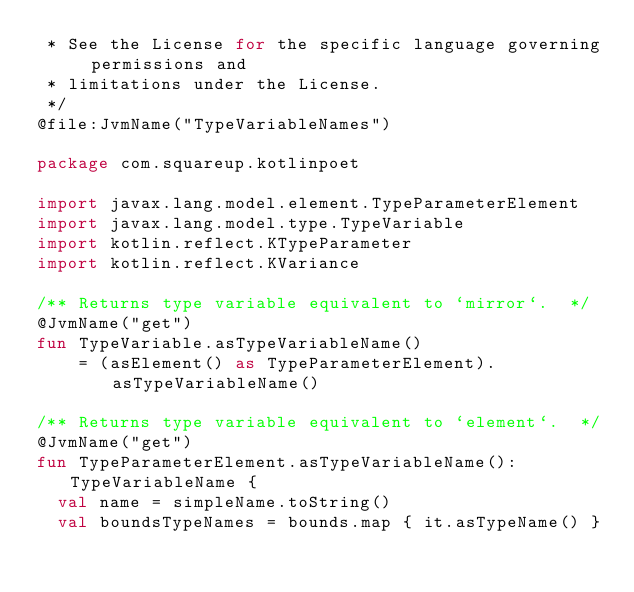Convert code to text. <code><loc_0><loc_0><loc_500><loc_500><_Kotlin_> * See the License for the specific language governing permissions and
 * limitations under the License.
 */
@file:JvmName("TypeVariableNames")

package com.squareup.kotlinpoet

import javax.lang.model.element.TypeParameterElement
import javax.lang.model.type.TypeVariable
import kotlin.reflect.KTypeParameter
import kotlin.reflect.KVariance

/** Returns type variable equivalent to `mirror`.  */
@JvmName("get")
fun TypeVariable.asTypeVariableName()
    = (asElement() as TypeParameterElement).asTypeVariableName()

/** Returns type variable equivalent to `element`.  */
@JvmName("get")
fun TypeParameterElement.asTypeVariableName(): TypeVariableName {
  val name = simpleName.toString()
  val boundsTypeNames = bounds.map { it.asTypeName() }</code> 